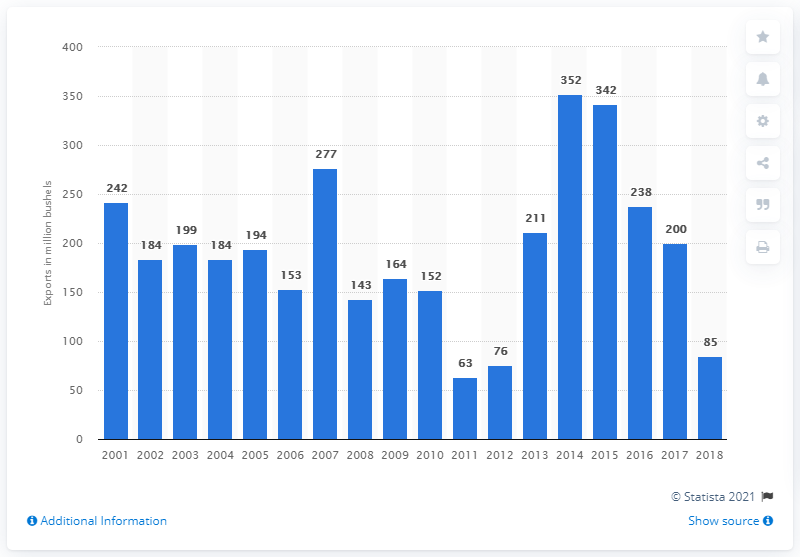Point out several critical features in this image. In 2018, the United States exported 85 bushels of sorghum. 